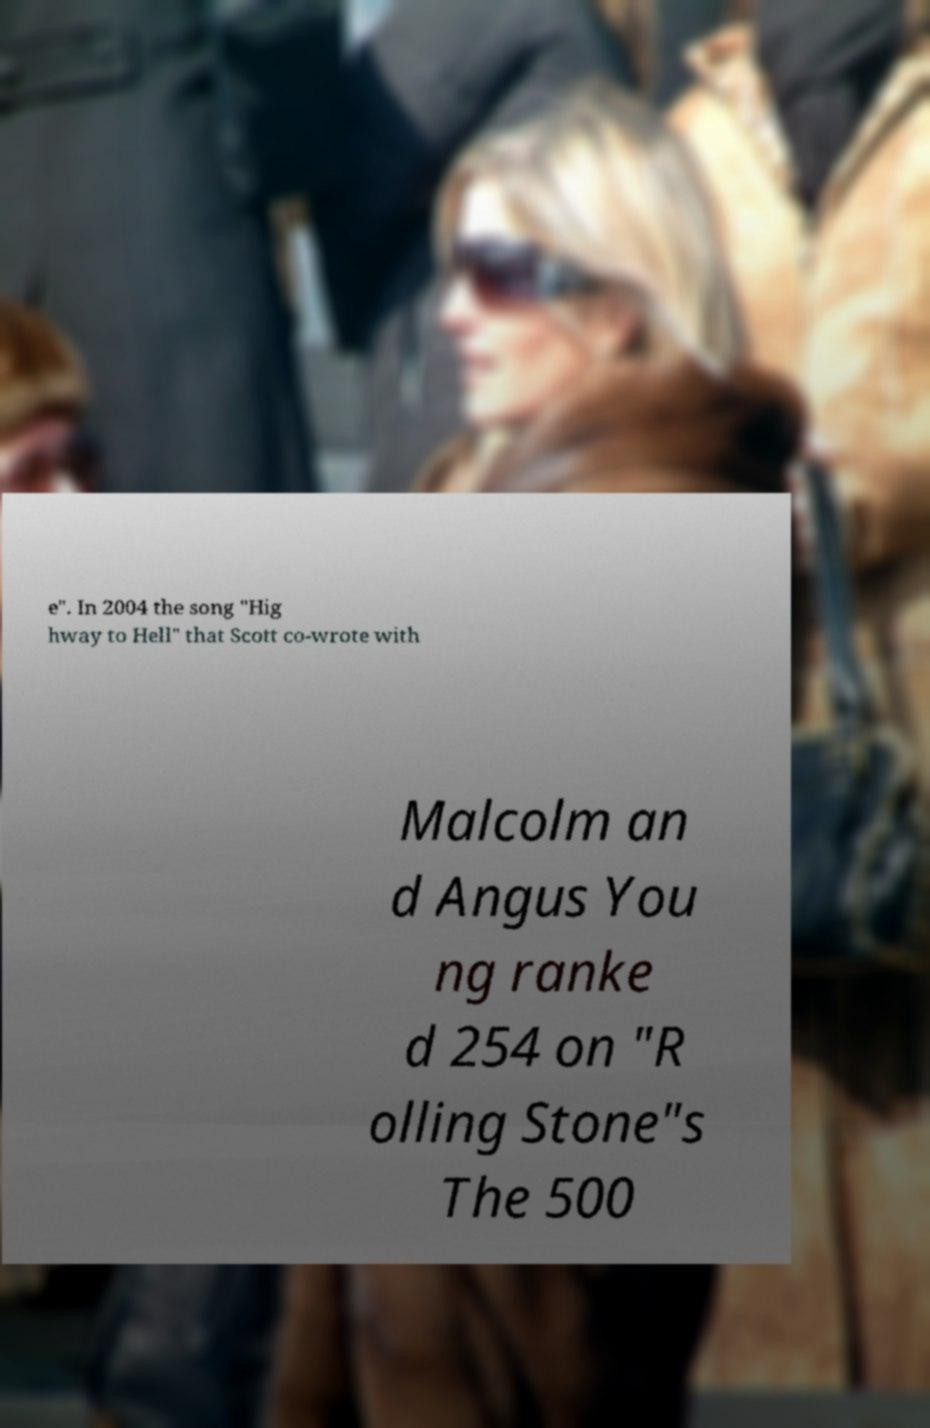Please read and relay the text visible in this image. What does it say? e". In 2004 the song "Hig hway to Hell" that Scott co-wrote with Malcolm an d Angus You ng ranke d 254 on "R olling Stone"s The 500 